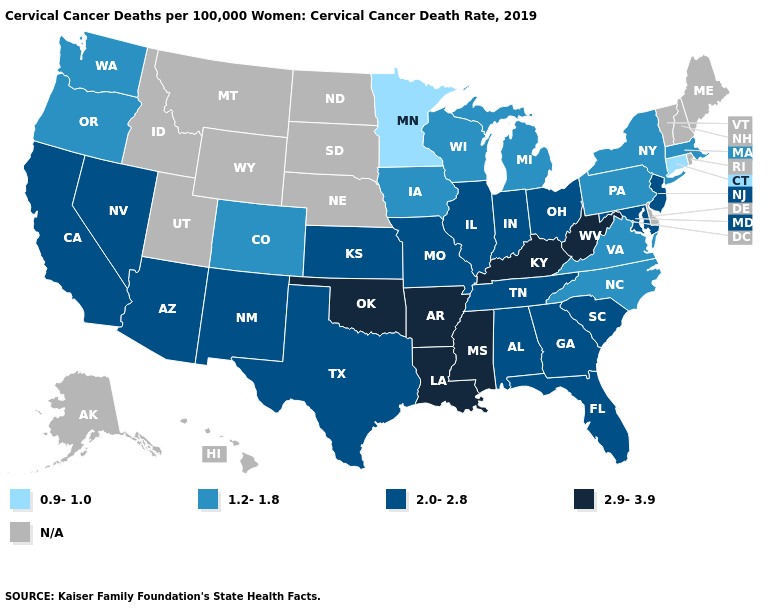Does the map have missing data?
Quick response, please. Yes. What is the value of Massachusetts?
Write a very short answer. 1.2-1.8. What is the value of Rhode Island?
Give a very brief answer. N/A. What is the value of New Hampshire?
Concise answer only. N/A. What is the lowest value in the MidWest?
Give a very brief answer. 0.9-1.0. Name the states that have a value in the range 0.9-1.0?
Keep it brief. Connecticut, Minnesota. Among the states that border Vermont , which have the highest value?
Write a very short answer. Massachusetts, New York. What is the lowest value in the MidWest?
Answer briefly. 0.9-1.0. What is the highest value in the USA?
Answer briefly. 2.9-3.9. What is the value of New Mexico?
Quick response, please. 2.0-2.8. Name the states that have a value in the range 0.9-1.0?
Write a very short answer. Connecticut, Minnesota. What is the highest value in states that border Connecticut?
Be succinct. 1.2-1.8. 